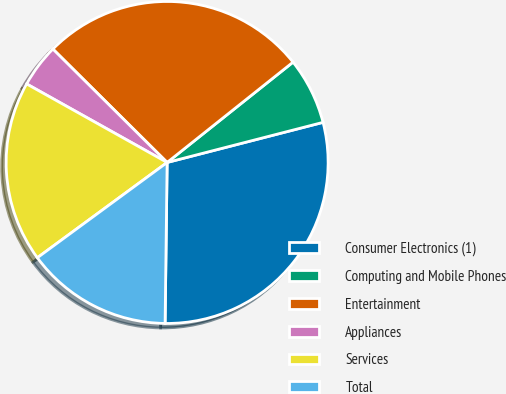Convert chart. <chart><loc_0><loc_0><loc_500><loc_500><pie_chart><fcel>Consumer Electronics (1)<fcel>Computing and Mobile Phones<fcel>Entertainment<fcel>Appliances<fcel>Services<fcel>Total<nl><fcel>29.21%<fcel>6.7%<fcel>26.85%<fcel>4.33%<fcel>18.19%<fcel>14.72%<nl></chart> 